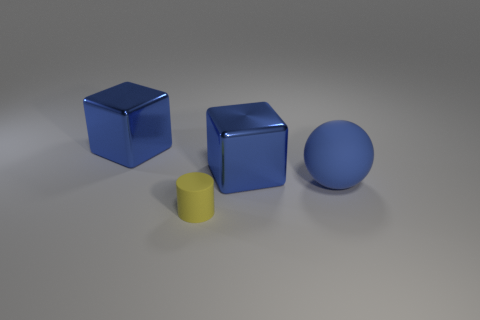Add 2 large metallic things. How many objects exist? 6 Subtract 1 balls. How many balls are left? 0 Add 4 tiny rubber cylinders. How many tiny rubber cylinders exist? 5 Subtract 0 cyan cylinders. How many objects are left? 4 Subtract all cylinders. How many objects are left? 3 Subtract all cyan spheres. Subtract all blue cylinders. How many spheres are left? 1 Subtract all rubber cylinders. Subtract all large blue blocks. How many objects are left? 1 Add 3 small yellow cylinders. How many small yellow cylinders are left? 4 